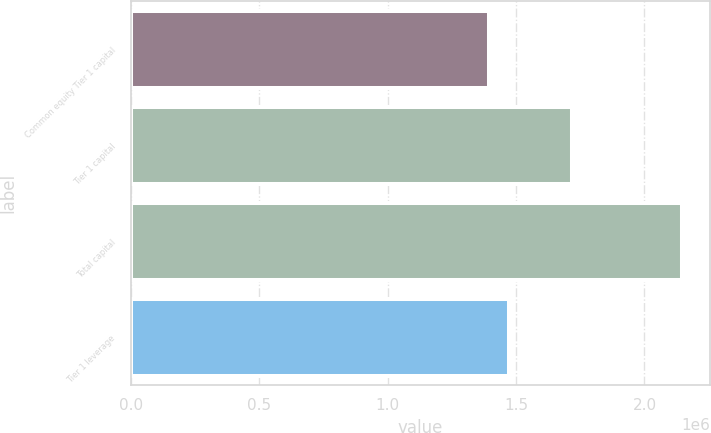Convert chart to OTSL. <chart><loc_0><loc_0><loc_500><loc_500><bar_chart><fcel>Common equity Tier 1 capital<fcel>Tier 1 capital<fcel>Total capital<fcel>Tier 1 leverage<nl><fcel>1.39582e+06<fcel>1.71794e+06<fcel>2.14742e+06<fcel>1.4723e+06<nl></chart> 